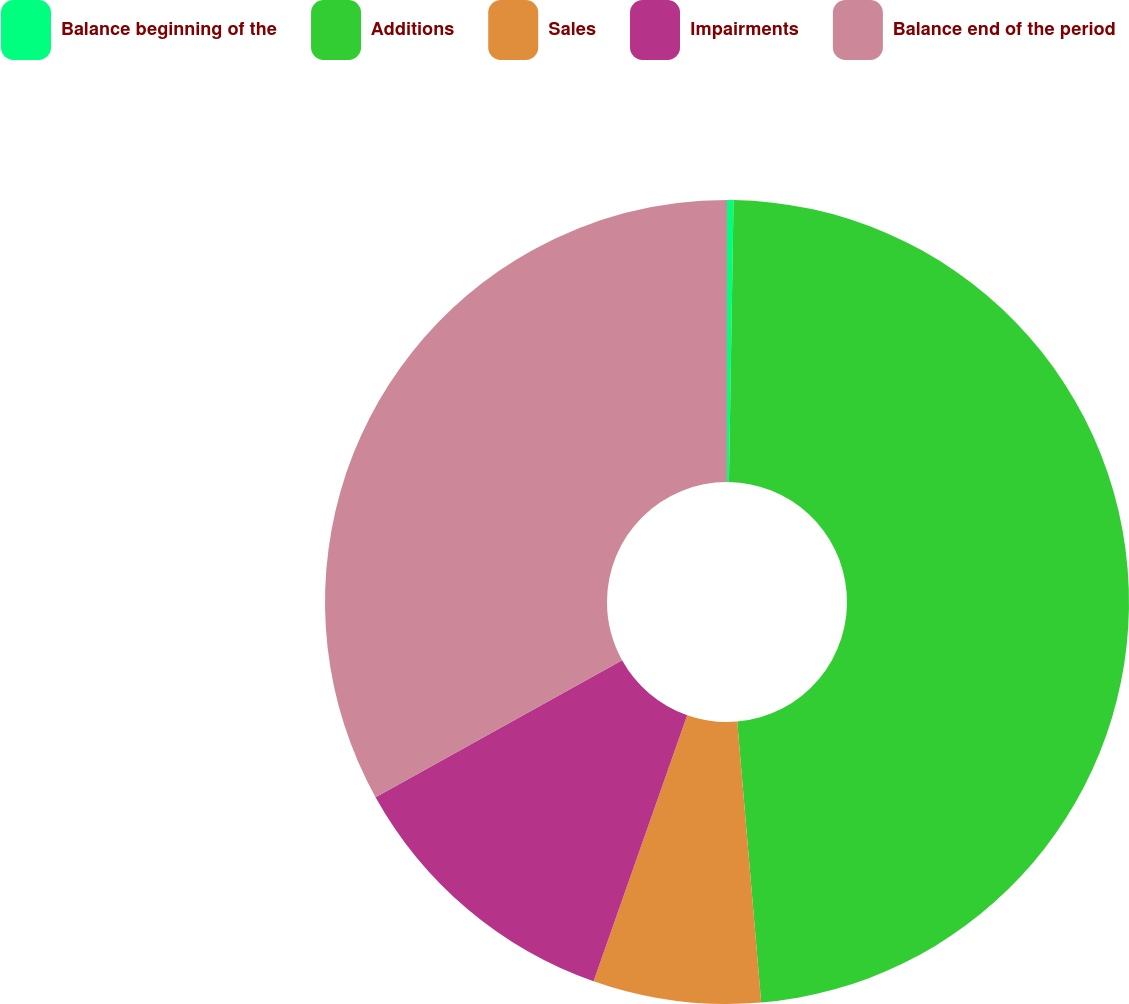<chart> <loc_0><loc_0><loc_500><loc_500><pie_chart><fcel>Balance beginning of the<fcel>Additions<fcel>Sales<fcel>Impairments<fcel>Balance end of the period<nl><fcel>0.26%<fcel>48.39%<fcel>6.74%<fcel>11.55%<fcel>33.07%<nl></chart> 